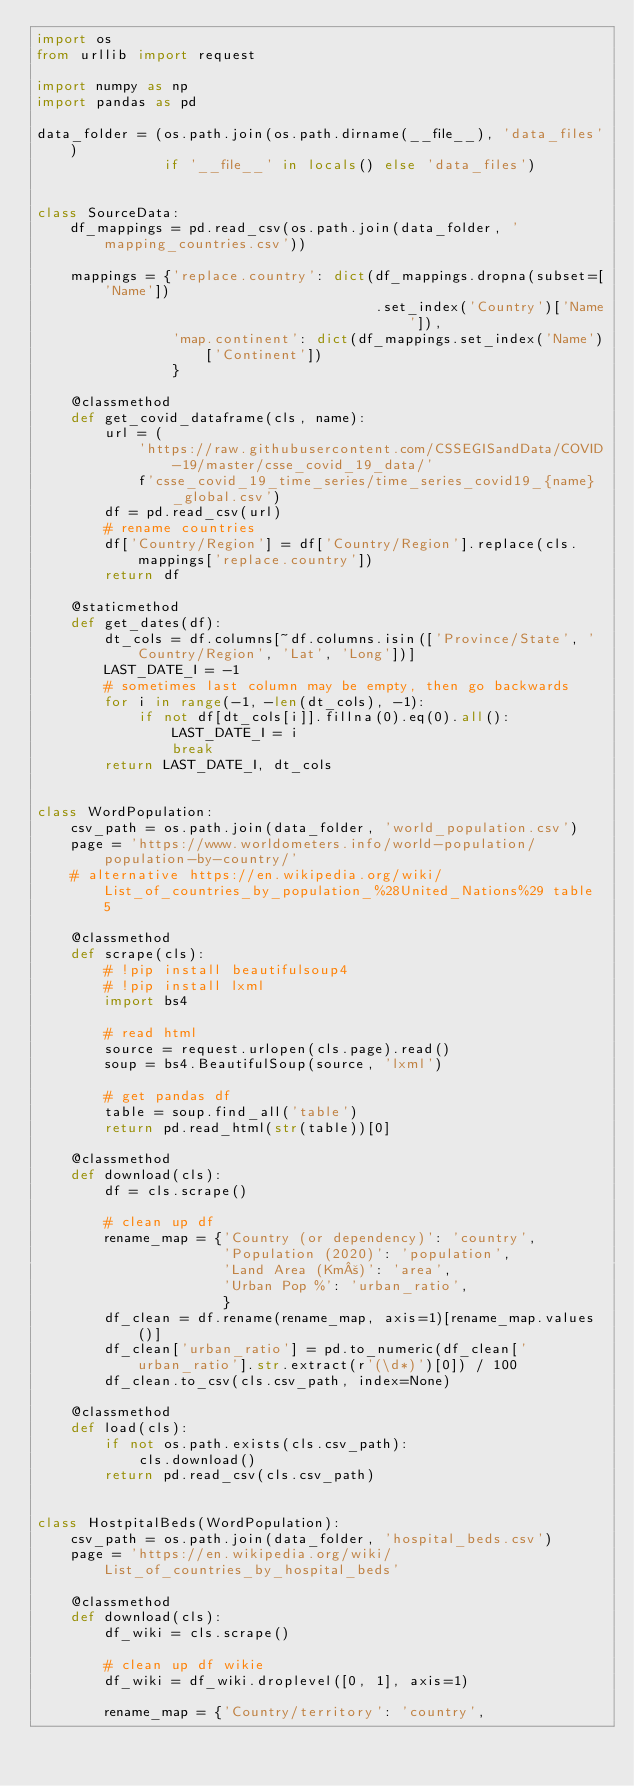Convert code to text. <code><loc_0><loc_0><loc_500><loc_500><_Python_>import os
from urllib import request

import numpy as np
import pandas as pd

data_folder = (os.path.join(os.path.dirname(__file__), 'data_files')
               if '__file__' in locals() else 'data_files')


class SourceData:
    df_mappings = pd.read_csv(os.path.join(data_folder, 'mapping_countries.csv'))

    mappings = {'replace.country': dict(df_mappings.dropna(subset=['Name'])
                                        .set_index('Country')['Name']),
                'map.continent': dict(df_mappings.set_index('Name')['Continent'])
                }

    @classmethod
    def get_covid_dataframe(cls, name):
        url = (
            'https://raw.githubusercontent.com/CSSEGISandData/COVID-19/master/csse_covid_19_data/'
            f'csse_covid_19_time_series/time_series_covid19_{name}_global.csv')
        df = pd.read_csv(url)
        # rename countries
        df['Country/Region'] = df['Country/Region'].replace(cls.mappings['replace.country'])
        return df

    @staticmethod
    def get_dates(df):
        dt_cols = df.columns[~df.columns.isin(['Province/State', 'Country/Region', 'Lat', 'Long'])]
        LAST_DATE_I = -1
        # sometimes last column may be empty, then go backwards
        for i in range(-1, -len(dt_cols), -1):
            if not df[dt_cols[i]].fillna(0).eq(0).all():
                LAST_DATE_I = i
                break
        return LAST_DATE_I, dt_cols


class WordPopulation:
    csv_path = os.path.join(data_folder, 'world_population.csv')
    page = 'https://www.worldometers.info/world-population/population-by-country/'
    # alternative https://en.wikipedia.org/wiki/List_of_countries_by_population_%28United_Nations%29 table 5

    @classmethod
    def scrape(cls):
        # !pip install beautifulsoup4
        # !pip install lxml
        import bs4

        # read html
        source = request.urlopen(cls.page).read()
        soup = bs4.BeautifulSoup(source, 'lxml')

        # get pandas df
        table = soup.find_all('table')
        return pd.read_html(str(table))[0]

    @classmethod
    def download(cls):
        df = cls.scrape()

        # clean up df
        rename_map = {'Country (or dependency)': 'country',
                      'Population (2020)': 'population',
                      'Land Area (Km²)': 'area',
                      'Urban Pop %': 'urban_ratio',
                      }
        df_clean = df.rename(rename_map, axis=1)[rename_map.values()]
        df_clean['urban_ratio'] = pd.to_numeric(df_clean['urban_ratio'].str.extract(r'(\d*)')[0]) / 100
        df_clean.to_csv(cls.csv_path, index=None)

    @classmethod
    def load(cls):
        if not os.path.exists(cls.csv_path):
            cls.download()
        return pd.read_csv(cls.csv_path)


class HostpitalBeds(WordPopulation):
    csv_path = os.path.join(data_folder, 'hospital_beds.csv')
    page = 'https://en.wikipedia.org/wiki/List_of_countries_by_hospital_beds'

    @classmethod
    def download(cls):
        df_wiki = cls.scrape()

        # clean up df wikie
        df_wiki = df_wiki.droplevel([0, 1], axis=1)

        rename_map = {'Country/territory': 'country',</code> 